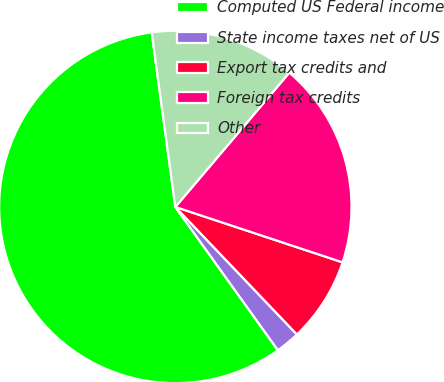<chart> <loc_0><loc_0><loc_500><loc_500><pie_chart><fcel>Computed US Federal income<fcel>State income taxes net of US<fcel>Export tax credits and<fcel>Foreign tax credits<fcel>Other<nl><fcel>57.75%<fcel>2.23%<fcel>7.79%<fcel>18.89%<fcel>13.34%<nl></chart> 